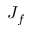<formula> <loc_0><loc_0><loc_500><loc_500>J _ { f }</formula> 